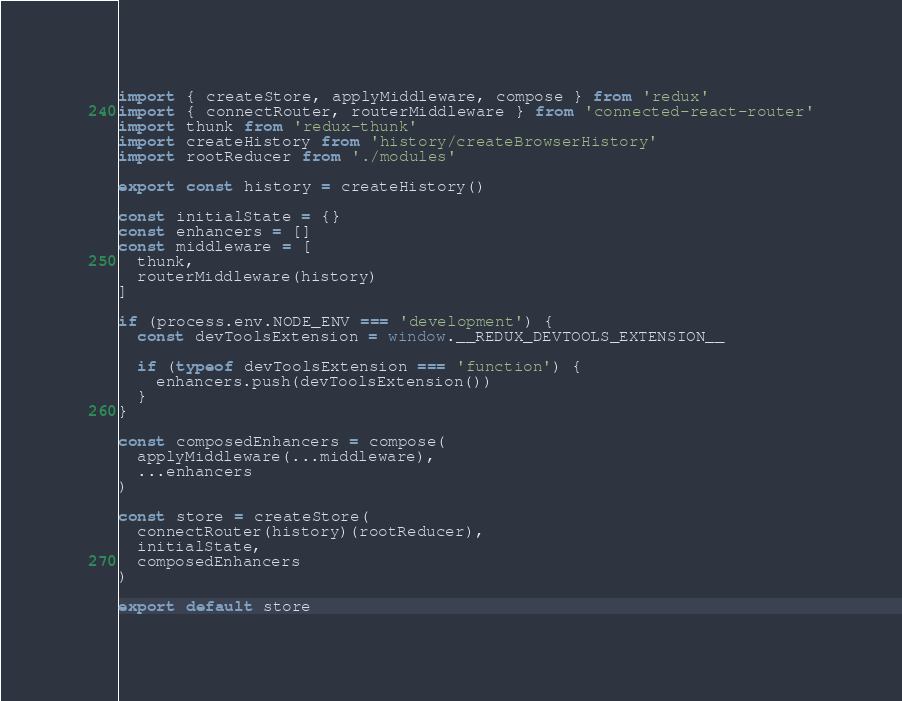Convert code to text. <code><loc_0><loc_0><loc_500><loc_500><_JavaScript_>import { createStore, applyMiddleware, compose } from 'redux'
import { connectRouter, routerMiddleware } from 'connected-react-router'
import thunk from 'redux-thunk'
import createHistory from 'history/createBrowserHistory'
import rootReducer from './modules'

export const history = createHistory()

const initialState = {}
const enhancers = []
const middleware = [
  thunk,
  routerMiddleware(history)
]

if (process.env.NODE_ENV === 'development') {
  const devToolsExtension = window.__REDUX_DEVTOOLS_EXTENSION__

  if (typeof devToolsExtension === 'function') {
    enhancers.push(devToolsExtension())
  }
}

const composedEnhancers = compose(
  applyMiddleware(...middleware),
  ...enhancers
)

const store = createStore(
  connectRouter(history)(rootReducer),
  initialState,
  composedEnhancers
)

export default store</code> 